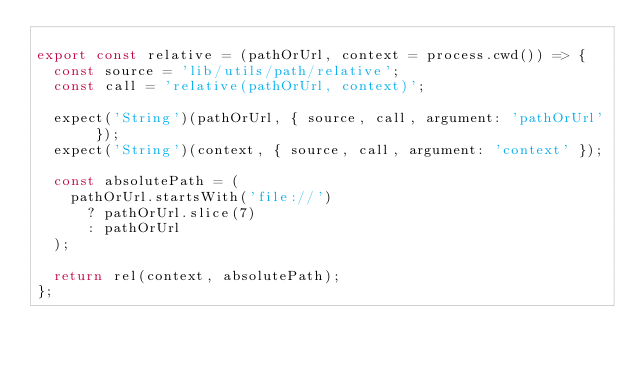<code> <loc_0><loc_0><loc_500><loc_500><_JavaScript_>
export const relative = (pathOrUrl, context = process.cwd()) => {
  const source = 'lib/utils/path/relative';
  const call = 'relative(pathOrUrl, context)';

  expect('String')(pathOrUrl, { source, call, argument: 'pathOrUrl' });
  expect('String')(context, { source, call, argument: 'context' });

  const absolutePath = (
    pathOrUrl.startsWith('file://')
      ? pathOrUrl.slice(7)
      : pathOrUrl
  );

  return rel(context, absolutePath);
};
</code> 